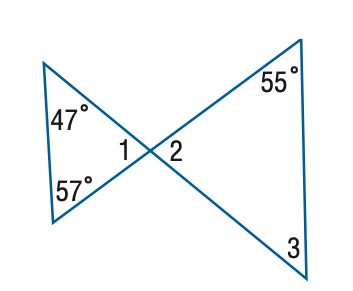Answer the mathemtical geometry problem and directly provide the correct option letter.
Question: Find the measure of \angle 3.
Choices: A: 47 B: 49 C: 55 D: 57 B 